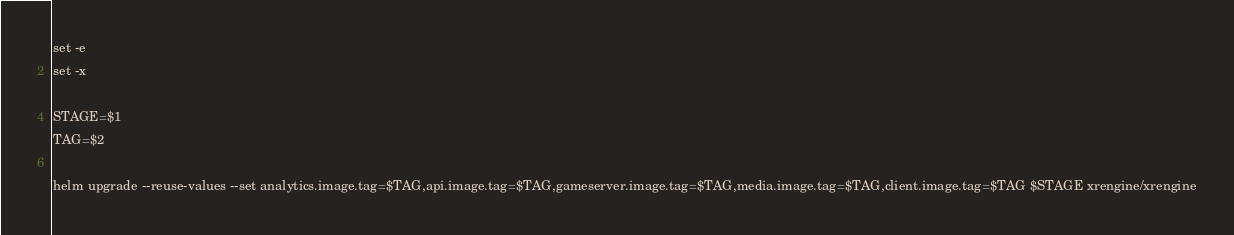Convert code to text. <code><loc_0><loc_0><loc_500><loc_500><_Bash_>set -e
set -x

STAGE=$1
TAG=$2

helm upgrade --reuse-values --set analytics.image.tag=$TAG,api.image.tag=$TAG,gameserver.image.tag=$TAG,media.image.tag=$TAG,client.image.tag=$TAG $STAGE xrengine/xrengine
</code> 